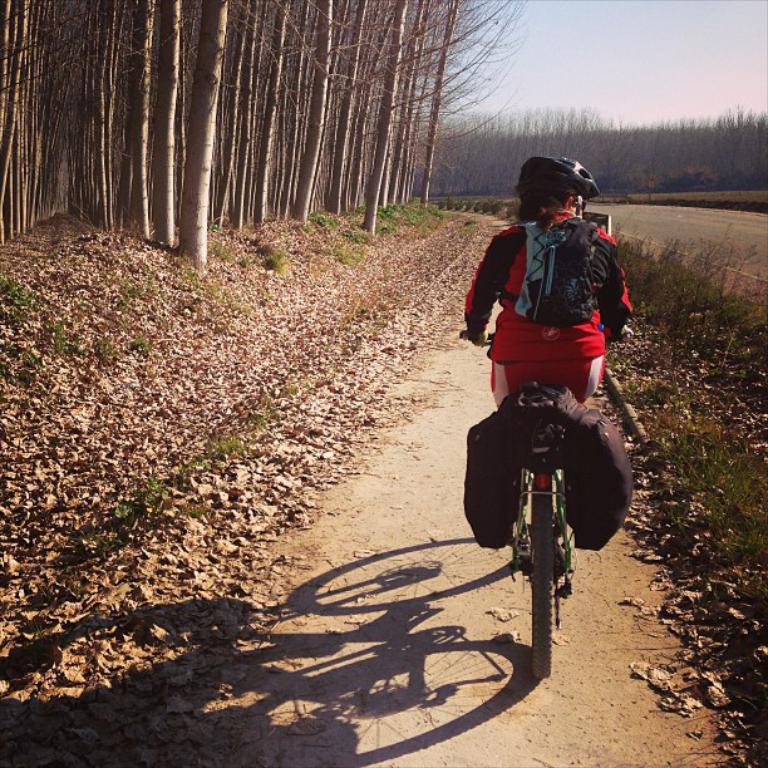Could you give a brief overview of what you see in this image? In this picture we can see a person is riding a bicycle, this person is wearing a backpack and a helmet, in the background there are some trees, we can see grass and leaves at the bottom, there is the sky at the top of the picture. 